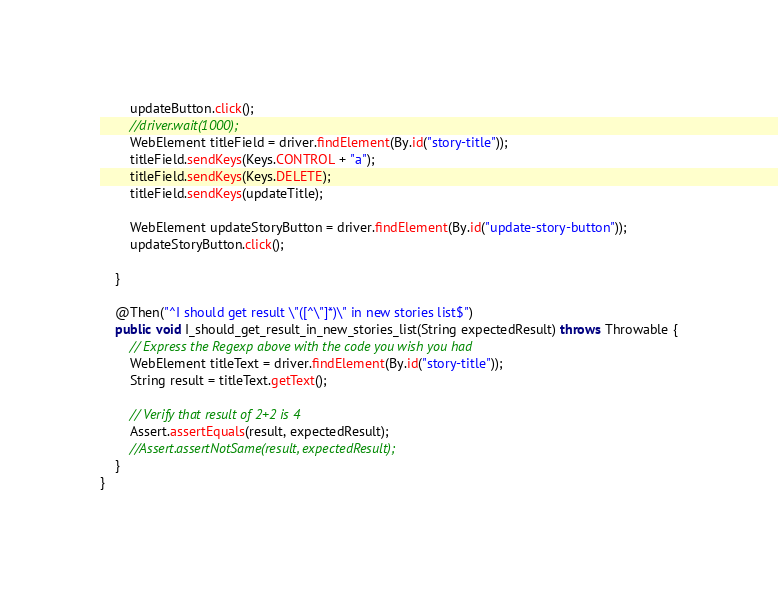Convert code to text. <code><loc_0><loc_0><loc_500><loc_500><_Java_>		updateButton.click();
		//driver.wait(1000);
		WebElement titleField = driver.findElement(By.id("story-title"));
		titleField.sendKeys(Keys.CONTROL + "a");
		titleField.sendKeys(Keys.DELETE);
		titleField.sendKeys(updateTitle);

		WebElement updateStoryButton = driver.findElement(By.id("update-story-button"));
		updateStoryButton.click();

	}

	@Then("^I should get result \"([^\"]*)\" in new stories list$")
	public void I_should_get_result_in_new_stories_list(String expectedResult) throws Throwable {
	    // Express the Regexp above with the code you wish you had
		WebElement titleText = driver.findElement(By.id("story-title"));
		String result = titleText.getText();

		// Verify that result of 2+2 is 4
		Assert.assertEquals(result, expectedResult);
		//Assert.assertNotSame(result, expectedResult);
	}
}
</code> 